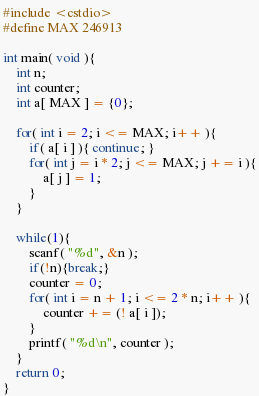<code> <loc_0><loc_0><loc_500><loc_500><_C++_>#include <cstdio>
#define MAX 246913

int main( void ){
	int n;
	int counter;
	int a[ MAX ] = {0};
	
	for( int i = 2; i <= MAX; i++ ){
		if( a[ i ] ){ continue; }
		for( int j = i * 2; j <= MAX; j += i ){
			a[ j ] = 1;
		}
	}
	
	while(1){
		scanf( "%d", &n ); 
		if(!n){break;}
		counter = 0;
		for( int i = n + 1; i <= 2 * n; i++ ){
			counter += (! a[ i ]);
		}
		printf( "%d\n", counter );
	}
	return 0;
}</code> 